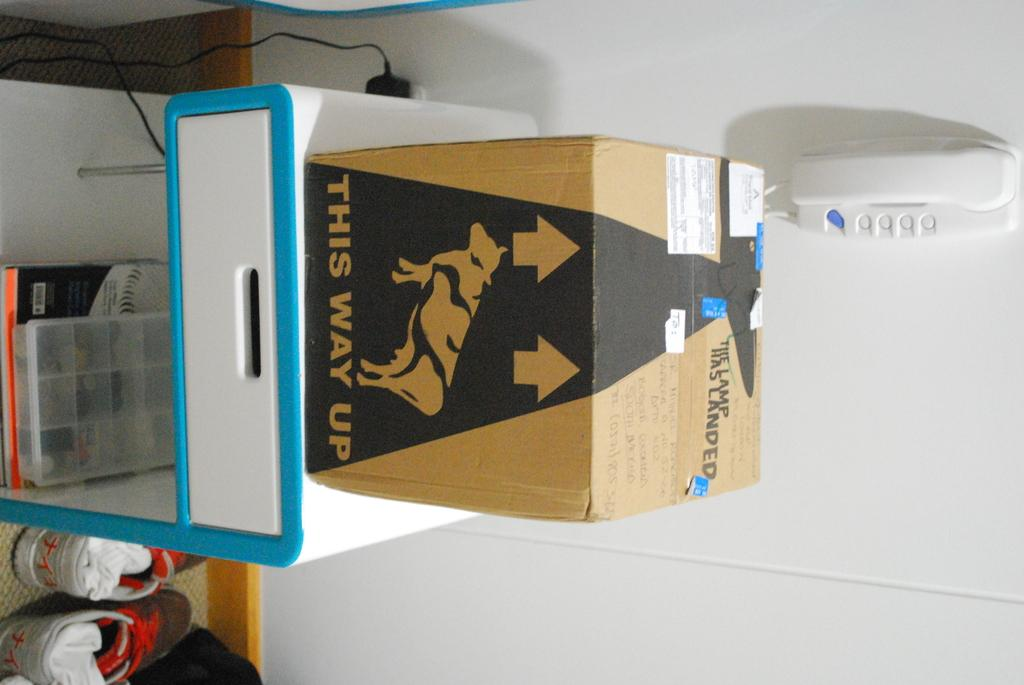Provide a one-sentence caption for the provided image. A cardboard box has an arrow and text of "this way up.". 